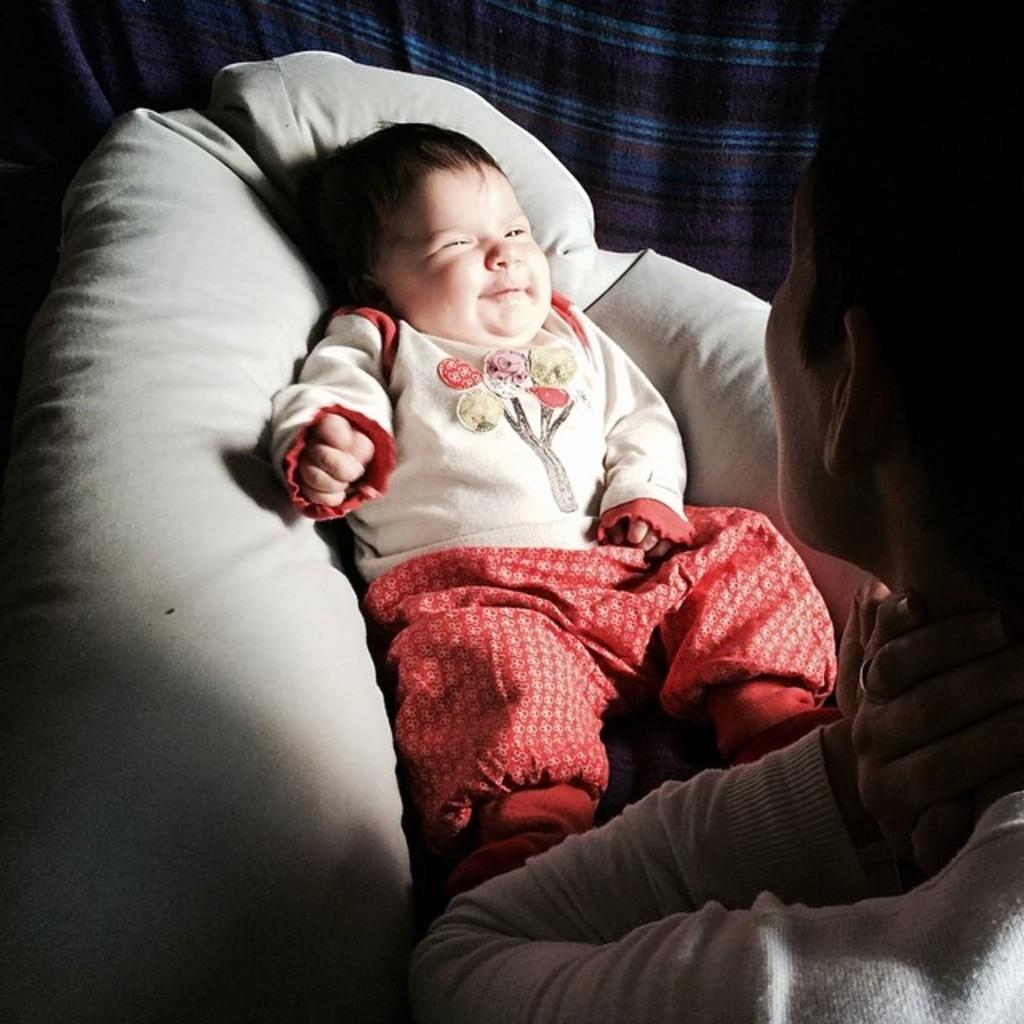Who is present in the image? There is a man in the picture. What is the man doing in the image? The man is looking at a baby. Where is the baby located in the image? The baby is on a bed. What can be seen in the background of the image? There is a cloth visible in the background. What color is the straw attached to the baby's tail in the image? There is no straw or baby with a tail present in the image. 